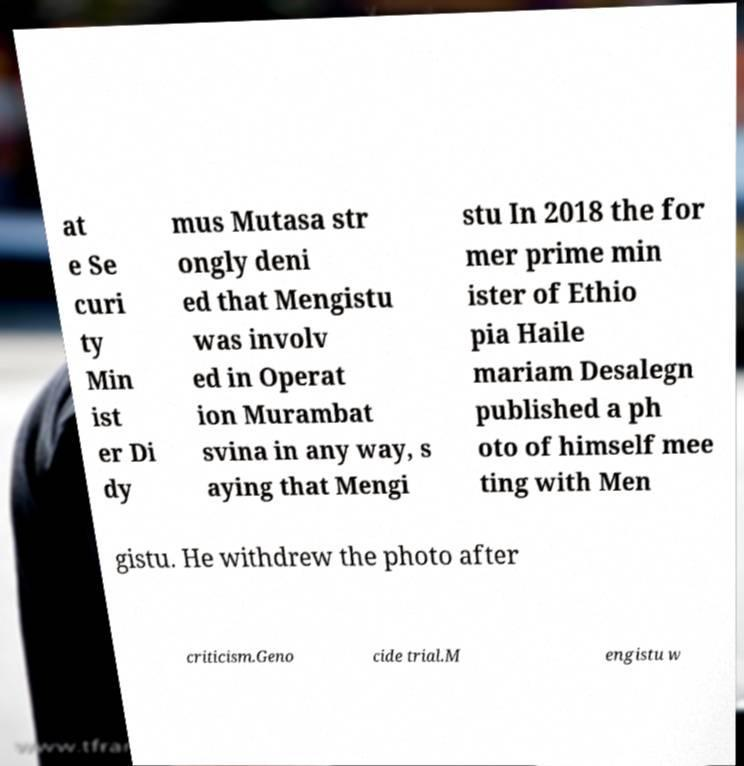For documentation purposes, I need the text within this image transcribed. Could you provide that? at e Se curi ty Min ist er Di dy mus Mutasa str ongly deni ed that Mengistu was involv ed in Operat ion Murambat svina in any way, s aying that Mengi stu In 2018 the for mer prime min ister of Ethio pia Haile mariam Desalegn published a ph oto of himself mee ting with Men gistu. He withdrew the photo after criticism.Geno cide trial.M engistu w 